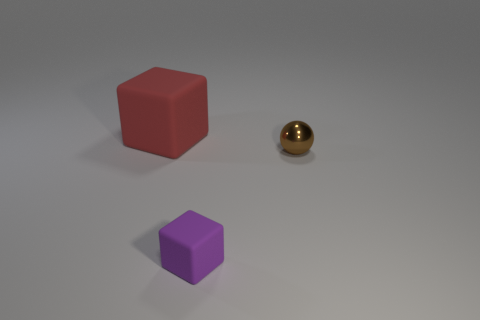Add 2 small gray matte objects. How many objects exist? 5 Subtract all balls. How many objects are left? 2 Add 2 brown metal objects. How many brown metal objects exist? 3 Subtract 0 blue blocks. How many objects are left? 3 Subtract all gray rubber blocks. Subtract all small rubber objects. How many objects are left? 2 Add 1 large red objects. How many large red objects are left? 2 